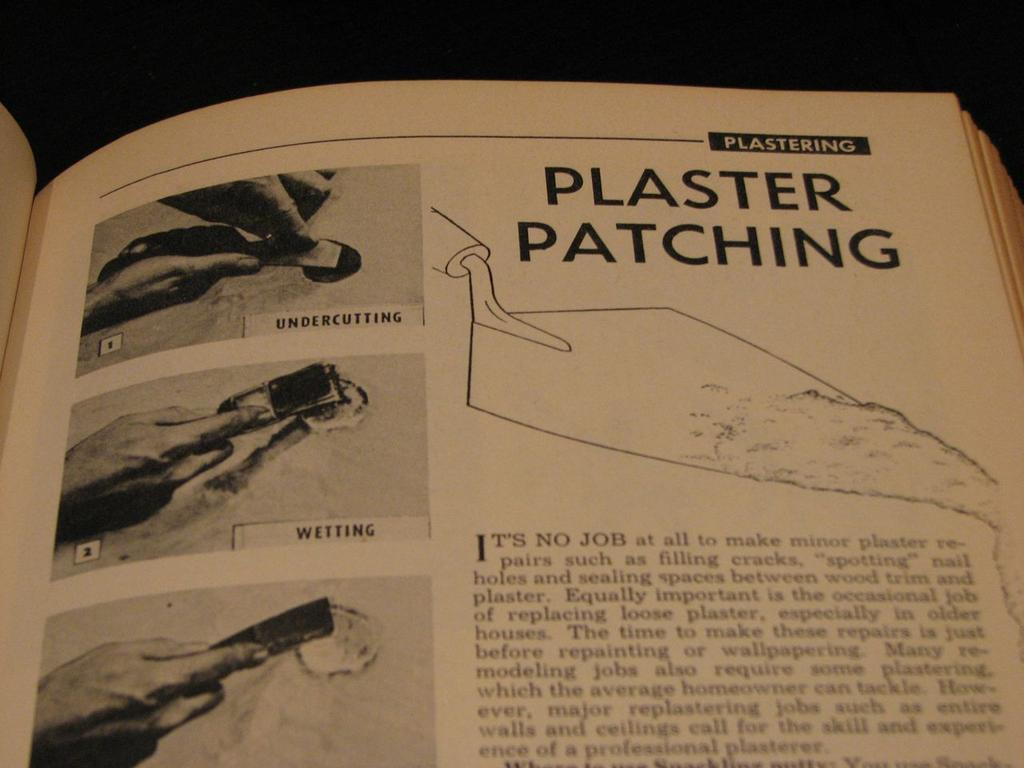What object can be seen in the image related to reading or learning? There is a book in the image. What body part is visible in the image? There is a hand in the image. What type of stomach can be seen in the image? There is no stomach visible in the image; only a book and a hand are present. Where is the park located in the image? There is no park present in the image. 